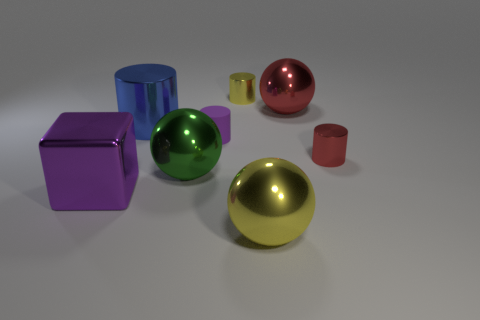Subtract all red spheres. How many spheres are left? 2 Add 2 large shiny cubes. How many objects exist? 10 Subtract all purple cylinders. How many cylinders are left? 3 Subtract all balls. How many objects are left? 5 Subtract all brown spheres. Subtract all brown cylinders. How many spheres are left? 3 Subtract 1 purple cylinders. How many objects are left? 7 Subtract all blue shiny cylinders. Subtract all large red metallic spheres. How many objects are left? 6 Add 8 large blue metallic objects. How many large blue metallic objects are left? 9 Add 2 blue shiny cylinders. How many blue shiny cylinders exist? 3 